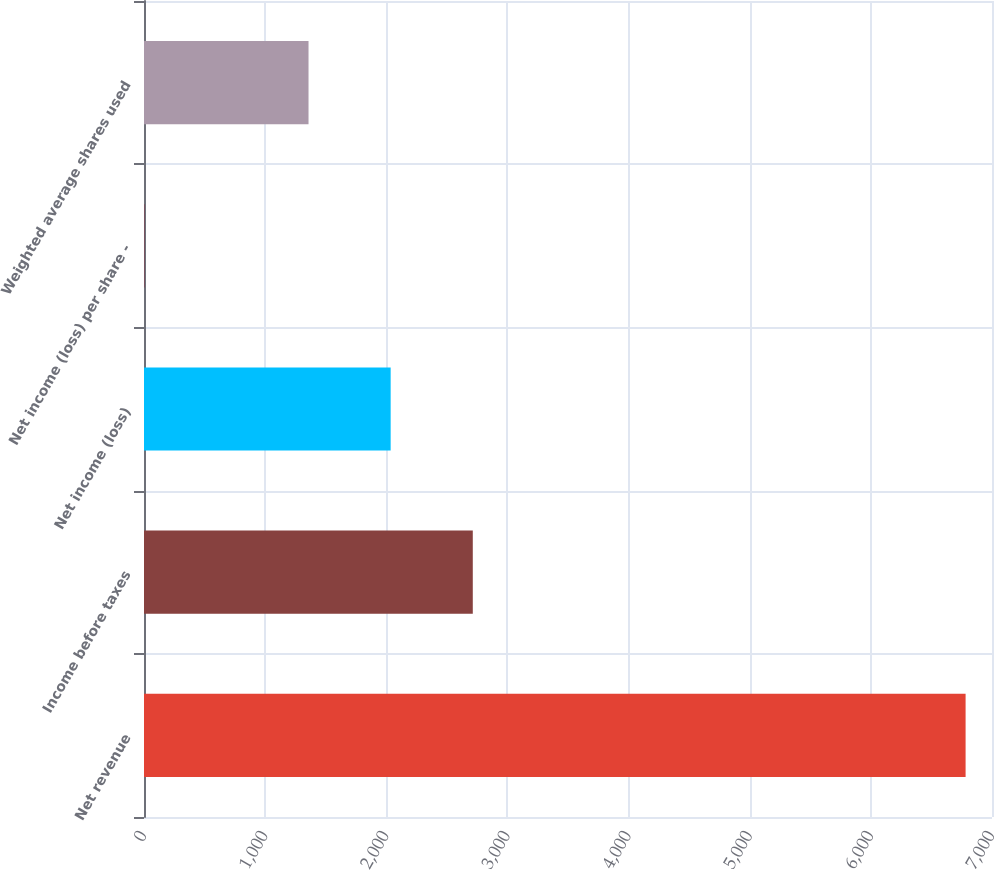<chart> <loc_0><loc_0><loc_500><loc_500><bar_chart><fcel>Net revenue<fcel>Income before taxes<fcel>Net income (loss)<fcel>Net income (loss) per share -<fcel>Weighted average shares used<nl><fcel>6782<fcel>2714.08<fcel>2036.09<fcel>2.12<fcel>1358.1<nl></chart> 